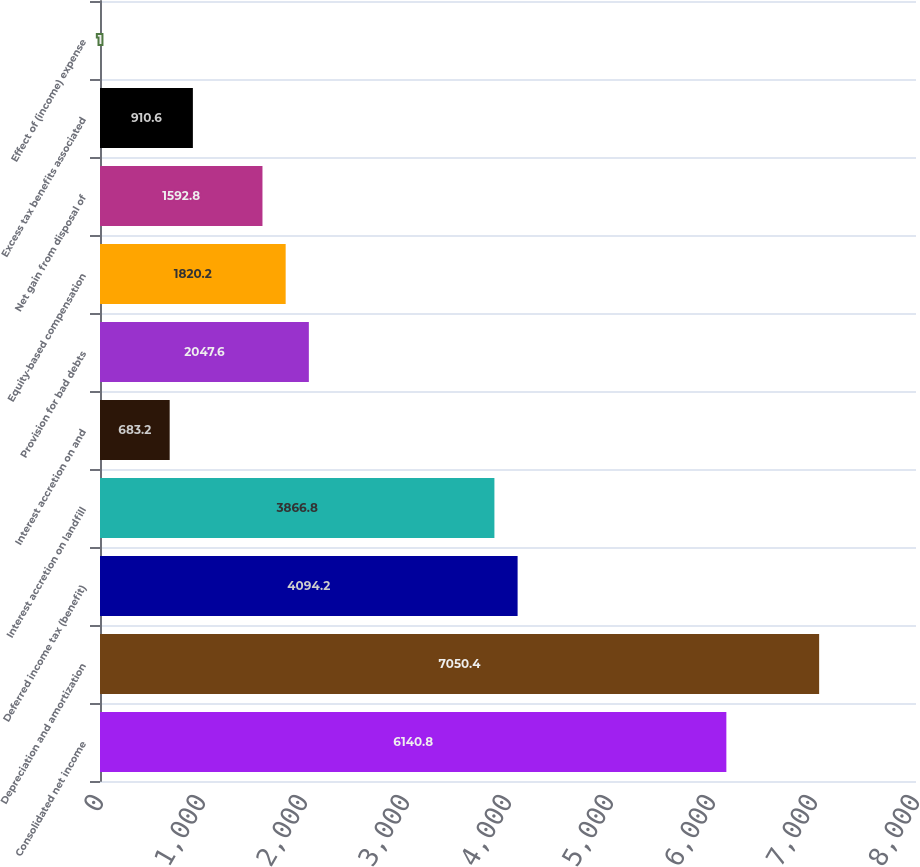Convert chart. <chart><loc_0><loc_0><loc_500><loc_500><bar_chart><fcel>Consolidated net income<fcel>Depreciation and amortization<fcel>Deferred income tax (benefit)<fcel>Interest accretion on landfill<fcel>Interest accretion on and<fcel>Provision for bad debts<fcel>Equity-based compensation<fcel>Net gain from disposal of<fcel>Excess tax benefits associated<fcel>Effect of (income) expense<nl><fcel>6140.8<fcel>7050.4<fcel>4094.2<fcel>3866.8<fcel>683.2<fcel>2047.6<fcel>1820.2<fcel>1592.8<fcel>910.6<fcel>1<nl></chart> 